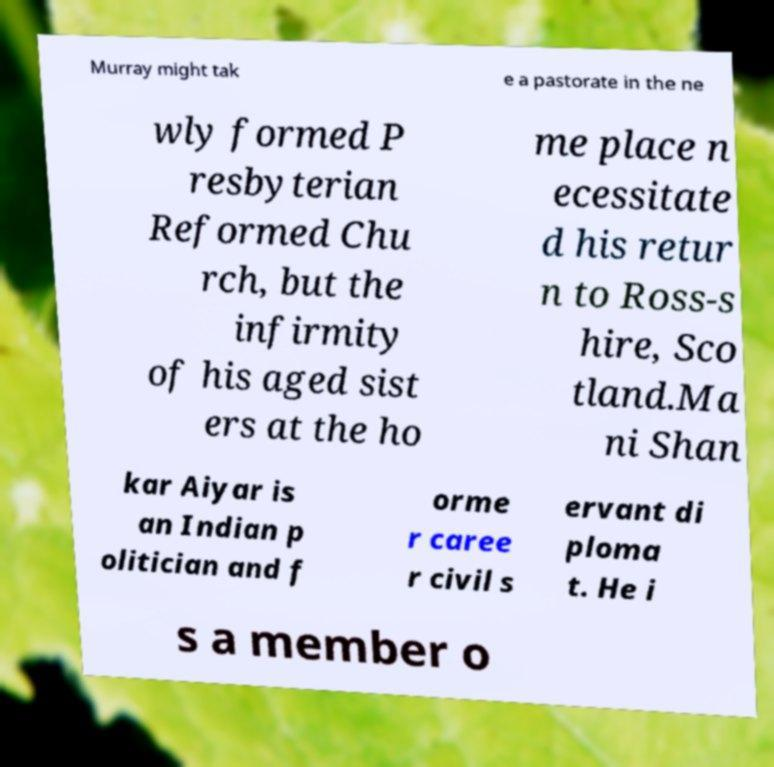Can you read and provide the text displayed in the image?This photo seems to have some interesting text. Can you extract and type it out for me? Murray might tak e a pastorate in the ne wly formed P resbyterian Reformed Chu rch, but the infirmity of his aged sist ers at the ho me place n ecessitate d his retur n to Ross-s hire, Sco tland.Ma ni Shan kar Aiyar is an Indian p olitician and f orme r caree r civil s ervant di ploma t. He i s a member o 